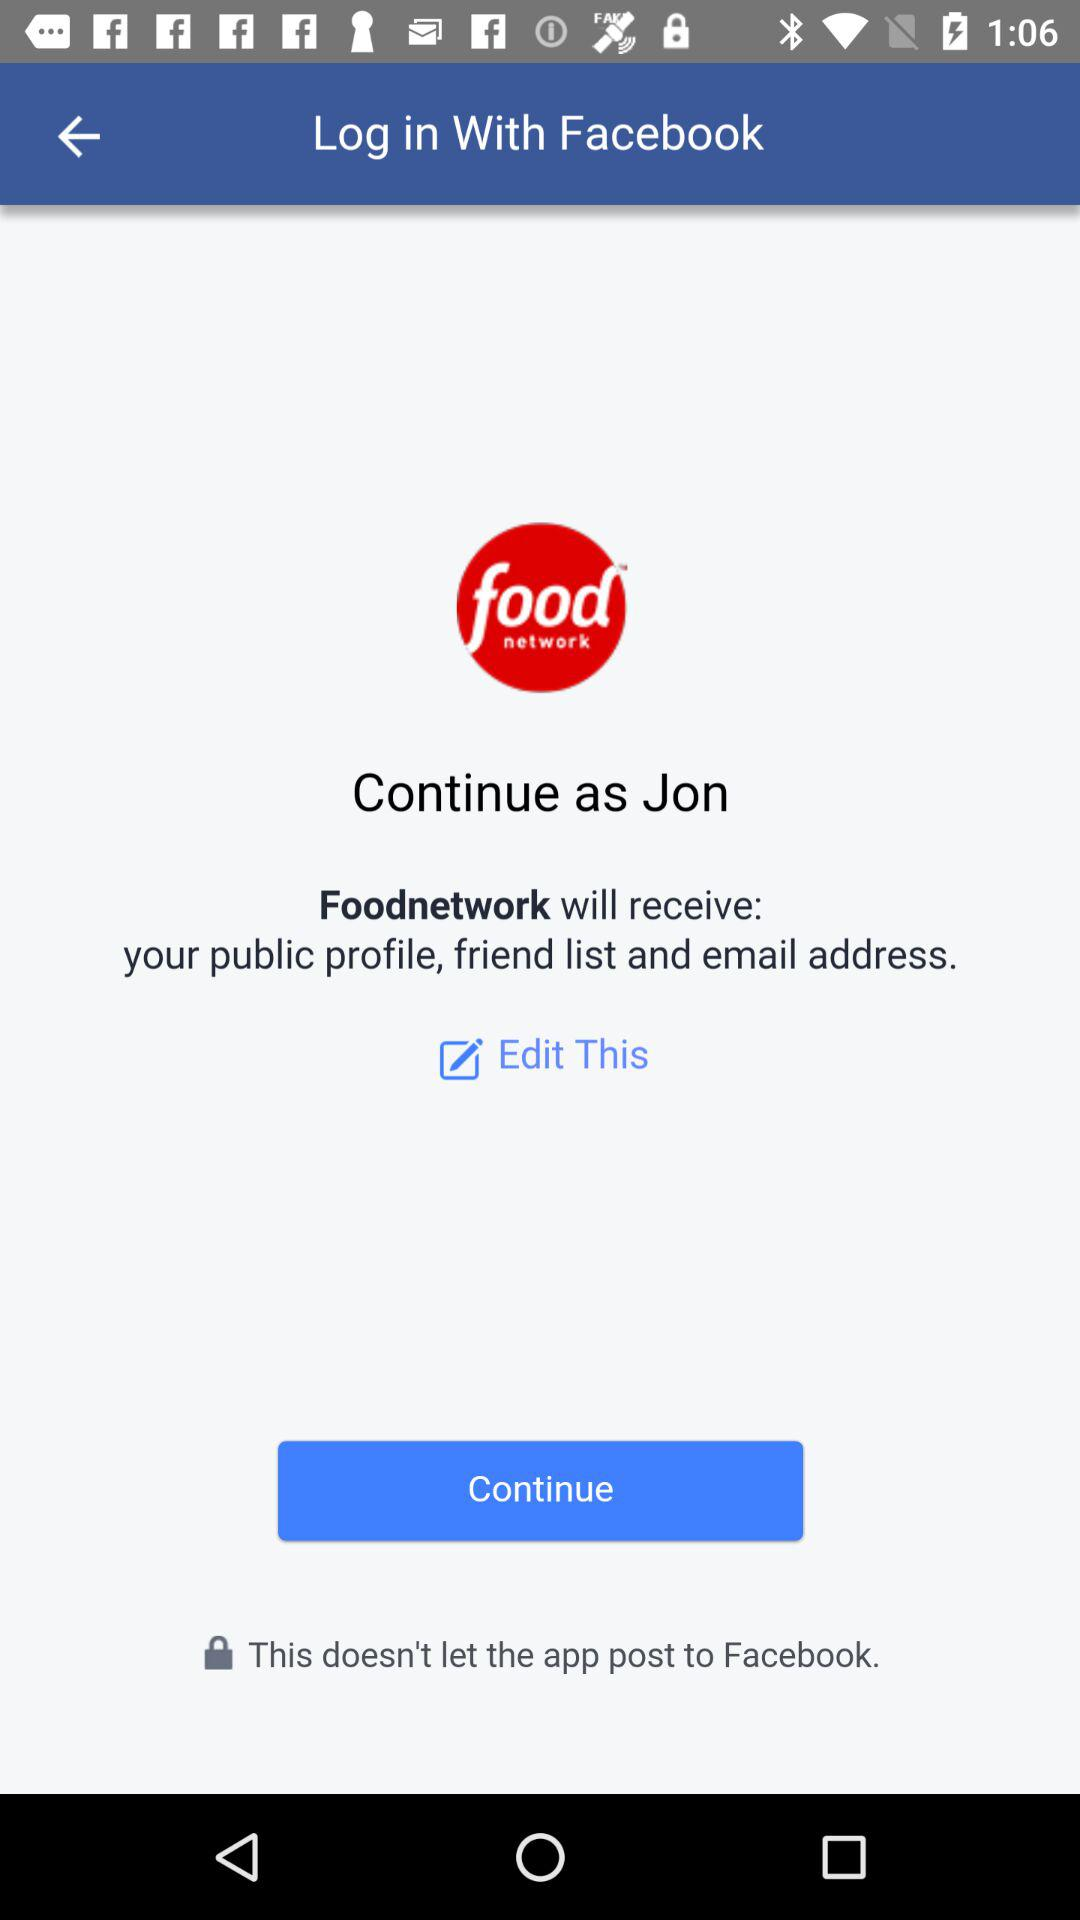Through which application can the user log in? The user can log in through "Facebook". 